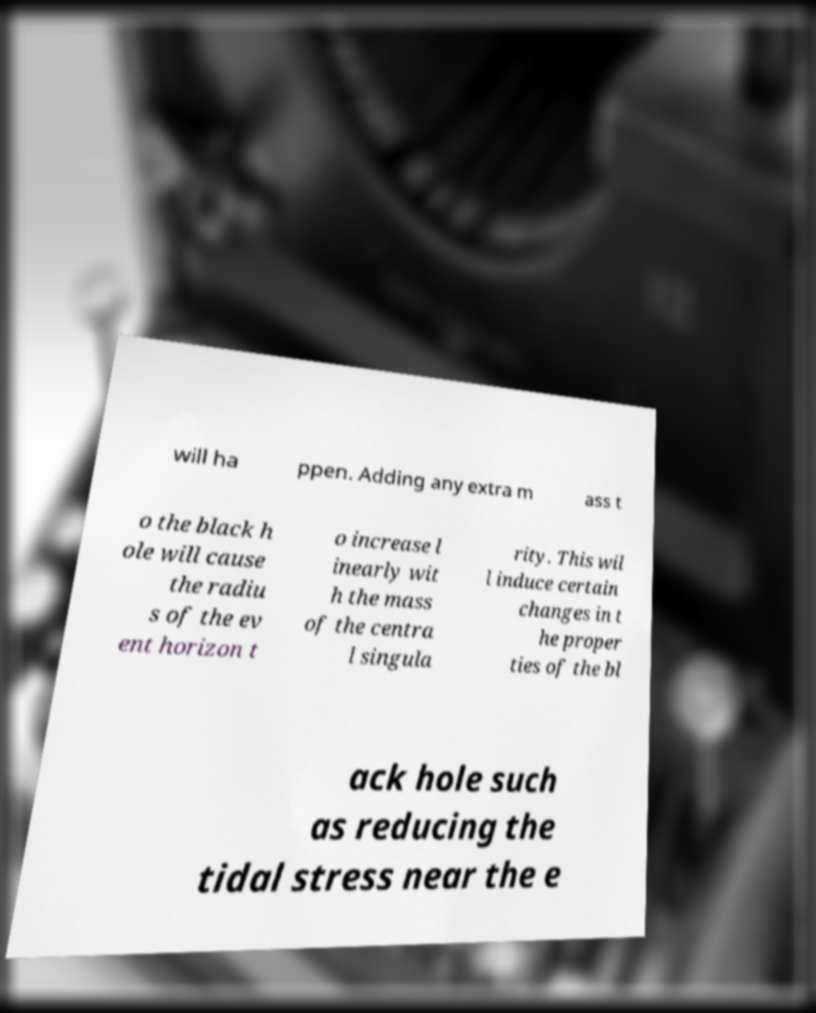There's text embedded in this image that I need extracted. Can you transcribe it verbatim? will ha ppen. Adding any extra m ass t o the black h ole will cause the radiu s of the ev ent horizon t o increase l inearly wit h the mass of the centra l singula rity. This wil l induce certain changes in t he proper ties of the bl ack hole such as reducing the tidal stress near the e 